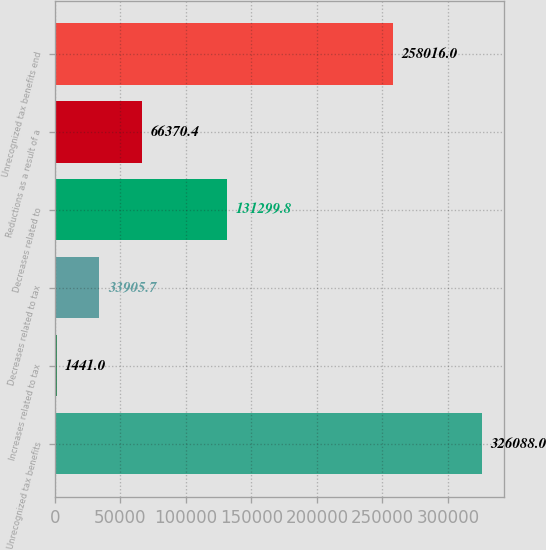<chart> <loc_0><loc_0><loc_500><loc_500><bar_chart><fcel>Unrecognized tax benefits<fcel>Increases related to tax<fcel>Decreases related to tax<fcel>Decreases related to<fcel>Reductions as a result of a<fcel>Unrecognized tax benefits end<nl><fcel>326088<fcel>1441<fcel>33905.7<fcel>131300<fcel>66370.4<fcel>258016<nl></chart> 